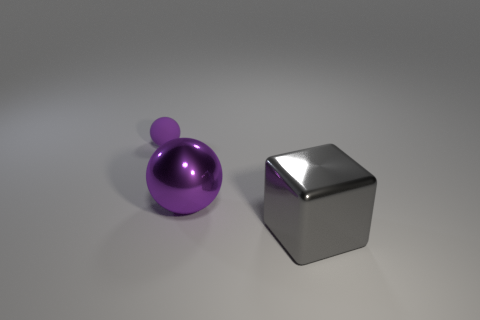Add 1 large gray metal cylinders. How many objects exist? 4 Subtract all balls. How many objects are left? 1 Add 1 purple rubber spheres. How many purple rubber spheres exist? 2 Subtract 1 purple balls. How many objects are left? 2 Subtract all big metal cubes. Subtract all big gray metallic objects. How many objects are left? 1 Add 2 large metallic objects. How many large metallic objects are left? 4 